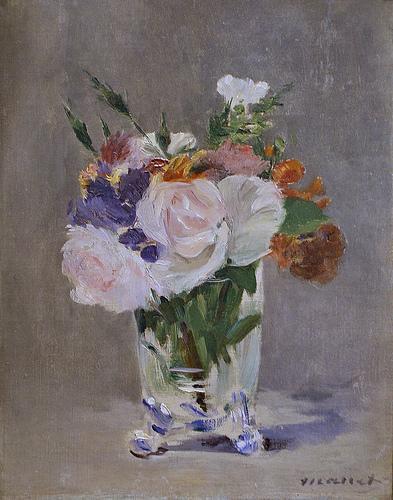How many types of flowers are shown?
Give a very brief answer. 3. 